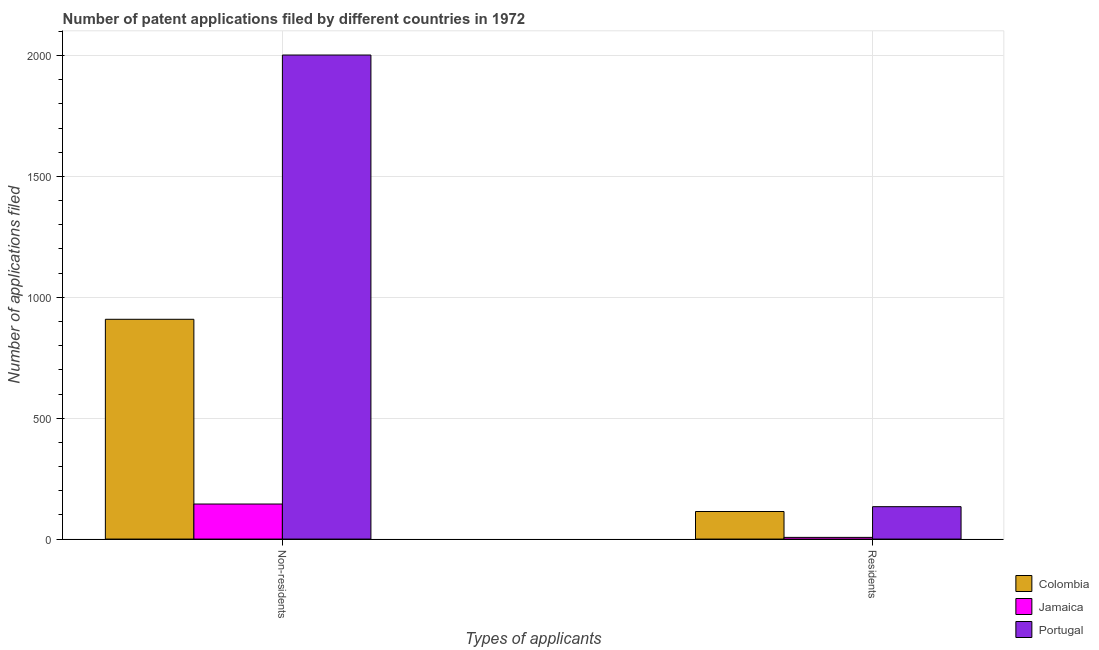How many different coloured bars are there?
Provide a succinct answer. 3. How many groups of bars are there?
Make the answer very short. 2. Are the number of bars per tick equal to the number of legend labels?
Your response must be concise. Yes. Are the number of bars on each tick of the X-axis equal?
Offer a very short reply. Yes. What is the label of the 2nd group of bars from the left?
Ensure brevity in your answer.  Residents. What is the number of patent applications by residents in Colombia?
Offer a very short reply. 114. Across all countries, what is the minimum number of patent applications by residents?
Ensure brevity in your answer.  7. In which country was the number of patent applications by residents minimum?
Offer a terse response. Jamaica. What is the total number of patent applications by residents in the graph?
Offer a very short reply. 255. What is the difference between the number of patent applications by residents in Colombia and that in Jamaica?
Offer a terse response. 107. What is the difference between the number of patent applications by non residents in Jamaica and the number of patent applications by residents in Portugal?
Offer a very short reply. 11. What is the difference between the number of patent applications by non residents and number of patent applications by residents in Portugal?
Keep it short and to the point. 1868. In how many countries, is the number of patent applications by non residents greater than 1400 ?
Ensure brevity in your answer.  1. What is the ratio of the number of patent applications by non residents in Jamaica to that in Portugal?
Offer a very short reply. 0.07. In how many countries, is the number of patent applications by non residents greater than the average number of patent applications by non residents taken over all countries?
Your answer should be compact. 1. What does the 2nd bar from the left in Non-residents represents?
Your answer should be very brief. Jamaica. What does the 2nd bar from the right in Residents represents?
Give a very brief answer. Jamaica. How many bars are there?
Provide a short and direct response. 6. Are all the bars in the graph horizontal?
Provide a short and direct response. No. How many countries are there in the graph?
Your answer should be compact. 3. What is the difference between two consecutive major ticks on the Y-axis?
Make the answer very short. 500. Does the graph contain any zero values?
Make the answer very short. No. Where does the legend appear in the graph?
Provide a short and direct response. Bottom right. How many legend labels are there?
Provide a short and direct response. 3. How are the legend labels stacked?
Your answer should be compact. Vertical. What is the title of the graph?
Your response must be concise. Number of patent applications filed by different countries in 1972. What is the label or title of the X-axis?
Provide a short and direct response. Types of applicants. What is the label or title of the Y-axis?
Your answer should be compact. Number of applications filed. What is the Number of applications filed of Colombia in Non-residents?
Your answer should be compact. 909. What is the Number of applications filed in Jamaica in Non-residents?
Provide a succinct answer. 145. What is the Number of applications filed of Portugal in Non-residents?
Provide a succinct answer. 2002. What is the Number of applications filed of Colombia in Residents?
Give a very brief answer. 114. What is the Number of applications filed in Jamaica in Residents?
Ensure brevity in your answer.  7. What is the Number of applications filed in Portugal in Residents?
Provide a succinct answer. 134. Across all Types of applicants, what is the maximum Number of applications filed in Colombia?
Your response must be concise. 909. Across all Types of applicants, what is the maximum Number of applications filed in Jamaica?
Offer a very short reply. 145. Across all Types of applicants, what is the maximum Number of applications filed in Portugal?
Provide a succinct answer. 2002. Across all Types of applicants, what is the minimum Number of applications filed of Colombia?
Provide a succinct answer. 114. Across all Types of applicants, what is the minimum Number of applications filed in Jamaica?
Keep it short and to the point. 7. Across all Types of applicants, what is the minimum Number of applications filed of Portugal?
Your answer should be very brief. 134. What is the total Number of applications filed of Colombia in the graph?
Offer a terse response. 1023. What is the total Number of applications filed in Jamaica in the graph?
Provide a succinct answer. 152. What is the total Number of applications filed of Portugal in the graph?
Ensure brevity in your answer.  2136. What is the difference between the Number of applications filed in Colombia in Non-residents and that in Residents?
Your answer should be compact. 795. What is the difference between the Number of applications filed in Jamaica in Non-residents and that in Residents?
Keep it short and to the point. 138. What is the difference between the Number of applications filed of Portugal in Non-residents and that in Residents?
Give a very brief answer. 1868. What is the difference between the Number of applications filed of Colombia in Non-residents and the Number of applications filed of Jamaica in Residents?
Your response must be concise. 902. What is the difference between the Number of applications filed in Colombia in Non-residents and the Number of applications filed in Portugal in Residents?
Offer a very short reply. 775. What is the average Number of applications filed of Colombia per Types of applicants?
Offer a very short reply. 511.5. What is the average Number of applications filed in Jamaica per Types of applicants?
Provide a short and direct response. 76. What is the average Number of applications filed in Portugal per Types of applicants?
Your answer should be very brief. 1068. What is the difference between the Number of applications filed of Colombia and Number of applications filed of Jamaica in Non-residents?
Provide a short and direct response. 764. What is the difference between the Number of applications filed of Colombia and Number of applications filed of Portugal in Non-residents?
Offer a very short reply. -1093. What is the difference between the Number of applications filed in Jamaica and Number of applications filed in Portugal in Non-residents?
Keep it short and to the point. -1857. What is the difference between the Number of applications filed in Colombia and Number of applications filed in Jamaica in Residents?
Your answer should be very brief. 107. What is the difference between the Number of applications filed of Colombia and Number of applications filed of Portugal in Residents?
Offer a terse response. -20. What is the difference between the Number of applications filed in Jamaica and Number of applications filed in Portugal in Residents?
Provide a succinct answer. -127. What is the ratio of the Number of applications filed in Colombia in Non-residents to that in Residents?
Give a very brief answer. 7.97. What is the ratio of the Number of applications filed in Jamaica in Non-residents to that in Residents?
Give a very brief answer. 20.71. What is the ratio of the Number of applications filed in Portugal in Non-residents to that in Residents?
Offer a terse response. 14.94. What is the difference between the highest and the second highest Number of applications filed of Colombia?
Your response must be concise. 795. What is the difference between the highest and the second highest Number of applications filed of Jamaica?
Give a very brief answer. 138. What is the difference between the highest and the second highest Number of applications filed of Portugal?
Provide a short and direct response. 1868. What is the difference between the highest and the lowest Number of applications filed of Colombia?
Ensure brevity in your answer.  795. What is the difference between the highest and the lowest Number of applications filed of Jamaica?
Your answer should be compact. 138. What is the difference between the highest and the lowest Number of applications filed in Portugal?
Offer a terse response. 1868. 